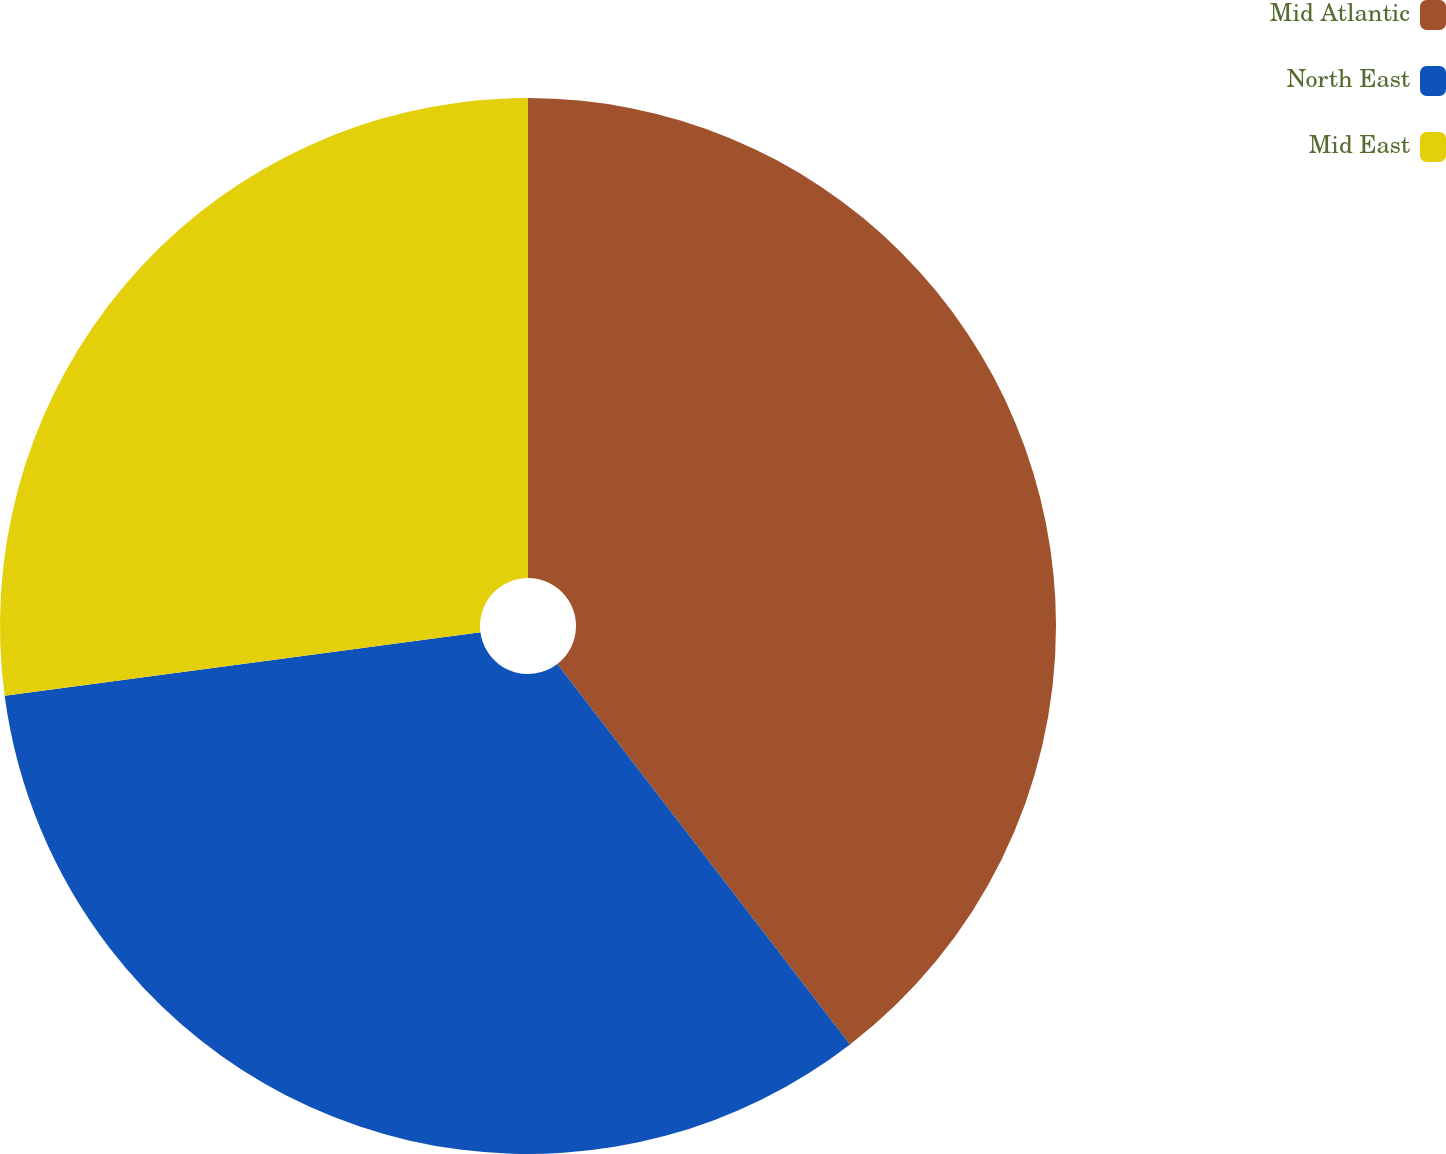Convert chart to OTSL. <chart><loc_0><loc_0><loc_500><loc_500><pie_chart><fcel>Mid Atlantic<fcel>North East<fcel>Mid East<nl><fcel>39.56%<fcel>33.33%<fcel>27.11%<nl></chart> 